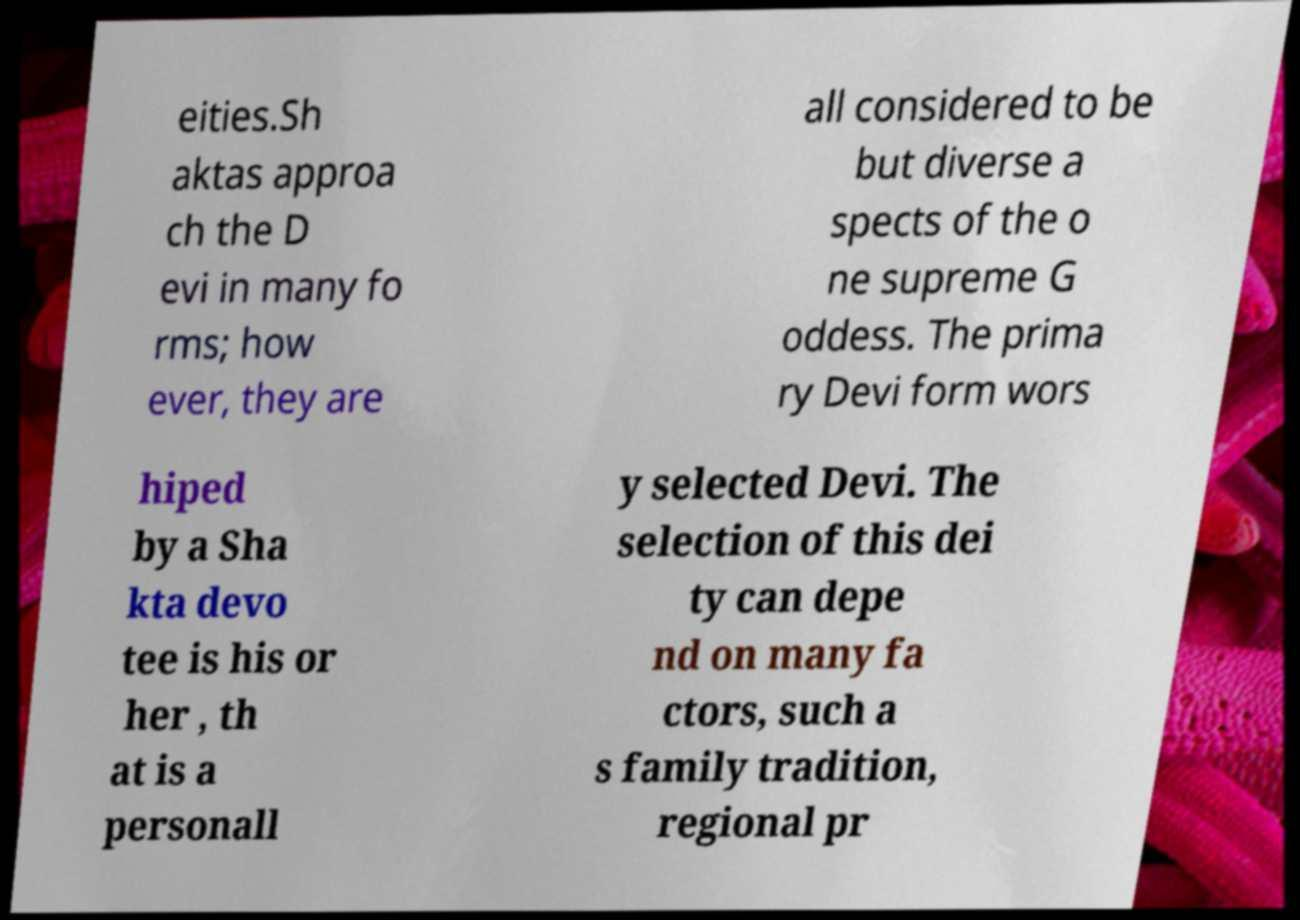Could you assist in decoding the text presented in this image and type it out clearly? eities.Sh aktas approa ch the D evi in many fo rms; how ever, they are all considered to be but diverse a spects of the o ne supreme G oddess. The prima ry Devi form wors hiped by a Sha kta devo tee is his or her , th at is a personall y selected Devi. The selection of this dei ty can depe nd on many fa ctors, such a s family tradition, regional pr 